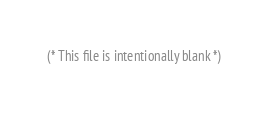Convert code to text. <code><loc_0><loc_0><loc_500><loc_500><_OCaml_>(* This file is intentionally blank *)
</code> 